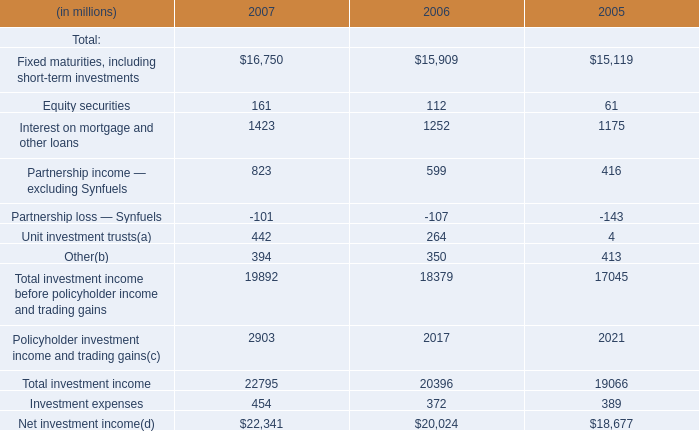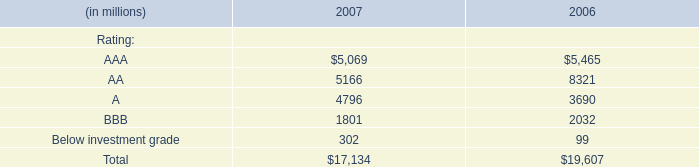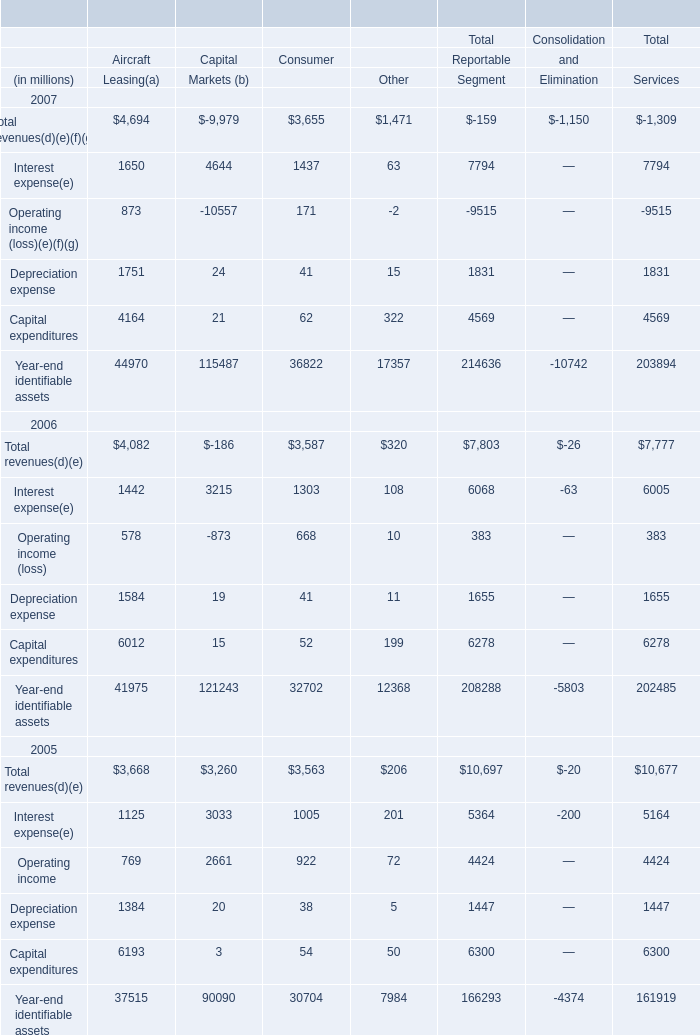What's the average of total revenues in Aricraft leasing in 2005, 2006, and 2007? (in $ in millions) 
Computations: (((3668 + 4082) + 4694) / 3)
Answer: 4148.0. 